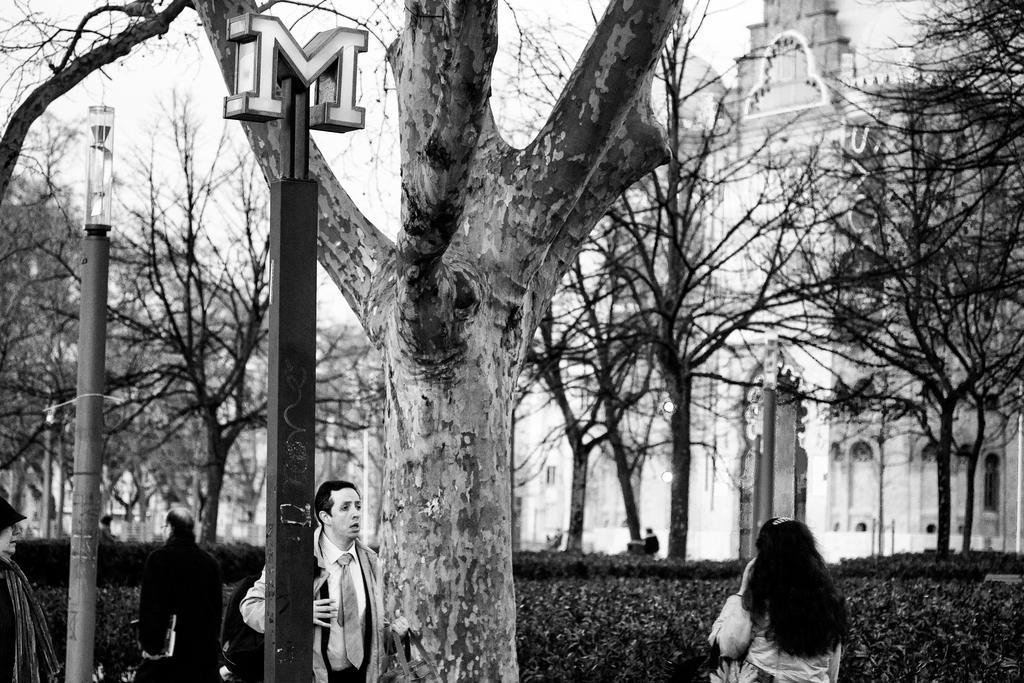Describe this image in one or two sentences. In the foreground of this black and white image, there is a tree, few poles and persons walking. In the background, there are plants, building, trees and the sky. 